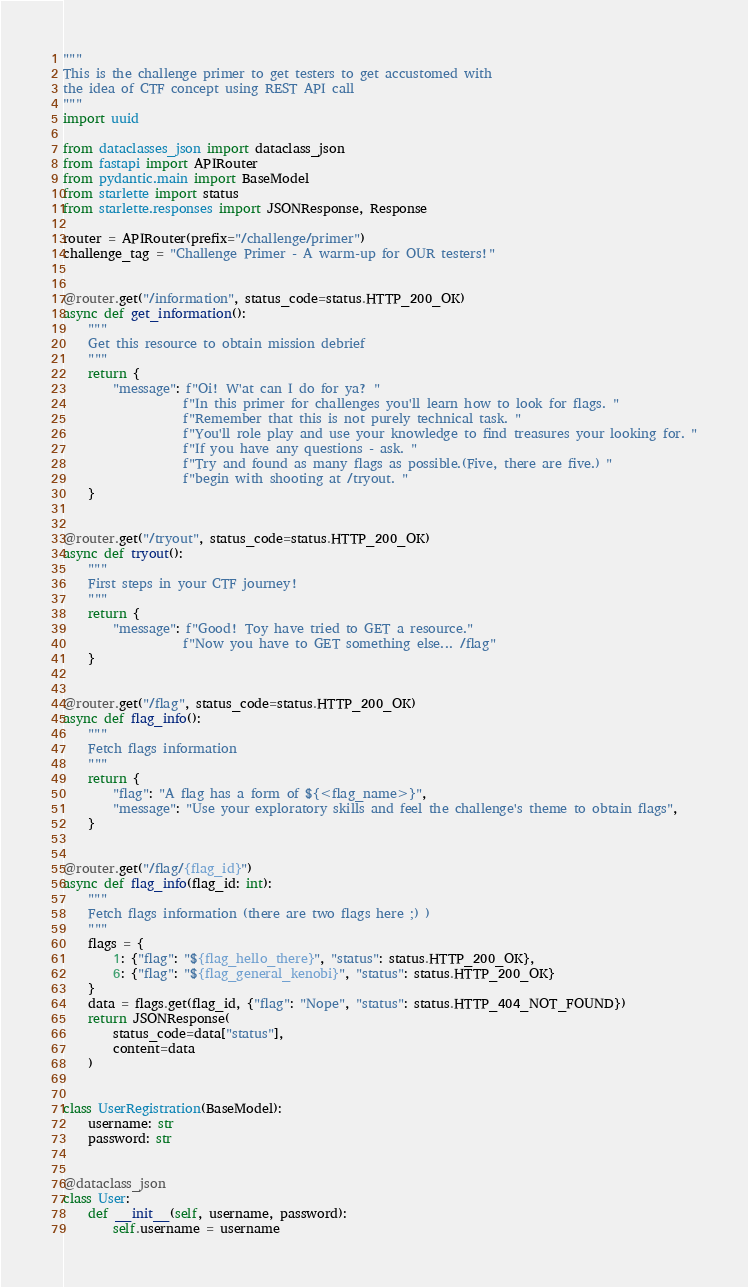Convert code to text. <code><loc_0><loc_0><loc_500><loc_500><_Python_>"""
This is the challenge primer to get testers to get accustomed with
the idea of CTF concept using REST API call
"""
import uuid

from dataclasses_json import dataclass_json
from fastapi import APIRouter
from pydantic.main import BaseModel
from starlette import status
from starlette.responses import JSONResponse, Response

router = APIRouter(prefix="/challenge/primer")
challenge_tag = "Challenge Primer - A warm-up for OUR testers!"


@router.get("/information", status_code=status.HTTP_200_OK)
async def get_information():
    """
    Get this resource to obtain mission debrief
    """
    return {
        "message": f"Oi! W'at can I do for ya? "
                   f"In this primer for challenges you'll learn how to look for flags. "
                   f"Remember that this is not purely technical task. "
                   f"You'll role play and use your knowledge to find treasures your looking for. "
                   f"If you have any questions - ask. "
                   f"Try and found as many flags as possible.(Five, there are five.) "
                   f"begin with shooting at /tryout. "
    }


@router.get("/tryout", status_code=status.HTTP_200_OK)
async def tryout():
    """
    First steps in your CTF journey!
    """
    return {
        "message": f"Good! Toy have tried to GET a resource."
                   f"Now you have to GET something else... /flag"
    }


@router.get("/flag", status_code=status.HTTP_200_OK)
async def flag_info():
    """
    Fetch flags information
    """
    return {
        "flag": "A flag has a form of ${<flag_name>}",
        "message": "Use your exploratory skills and feel the challenge's theme to obtain flags",
    }


@router.get("/flag/{flag_id}")
async def flag_info(flag_id: int):
    """
    Fetch flags information (there are two flags here ;) )
    """
    flags = {
        1: {"flag": "${flag_hello_there}", "status": status.HTTP_200_OK},
        6: {"flag": "${flag_general_kenobi}", "status": status.HTTP_200_OK}
    }
    data = flags.get(flag_id, {"flag": "Nope", "status": status.HTTP_404_NOT_FOUND})
    return JSONResponse(
        status_code=data["status"],
        content=data
    )


class UserRegistration(BaseModel):
    username: str
    password: str


@dataclass_json
class User:
    def __init__(self, username, password):
        self.username = username</code> 